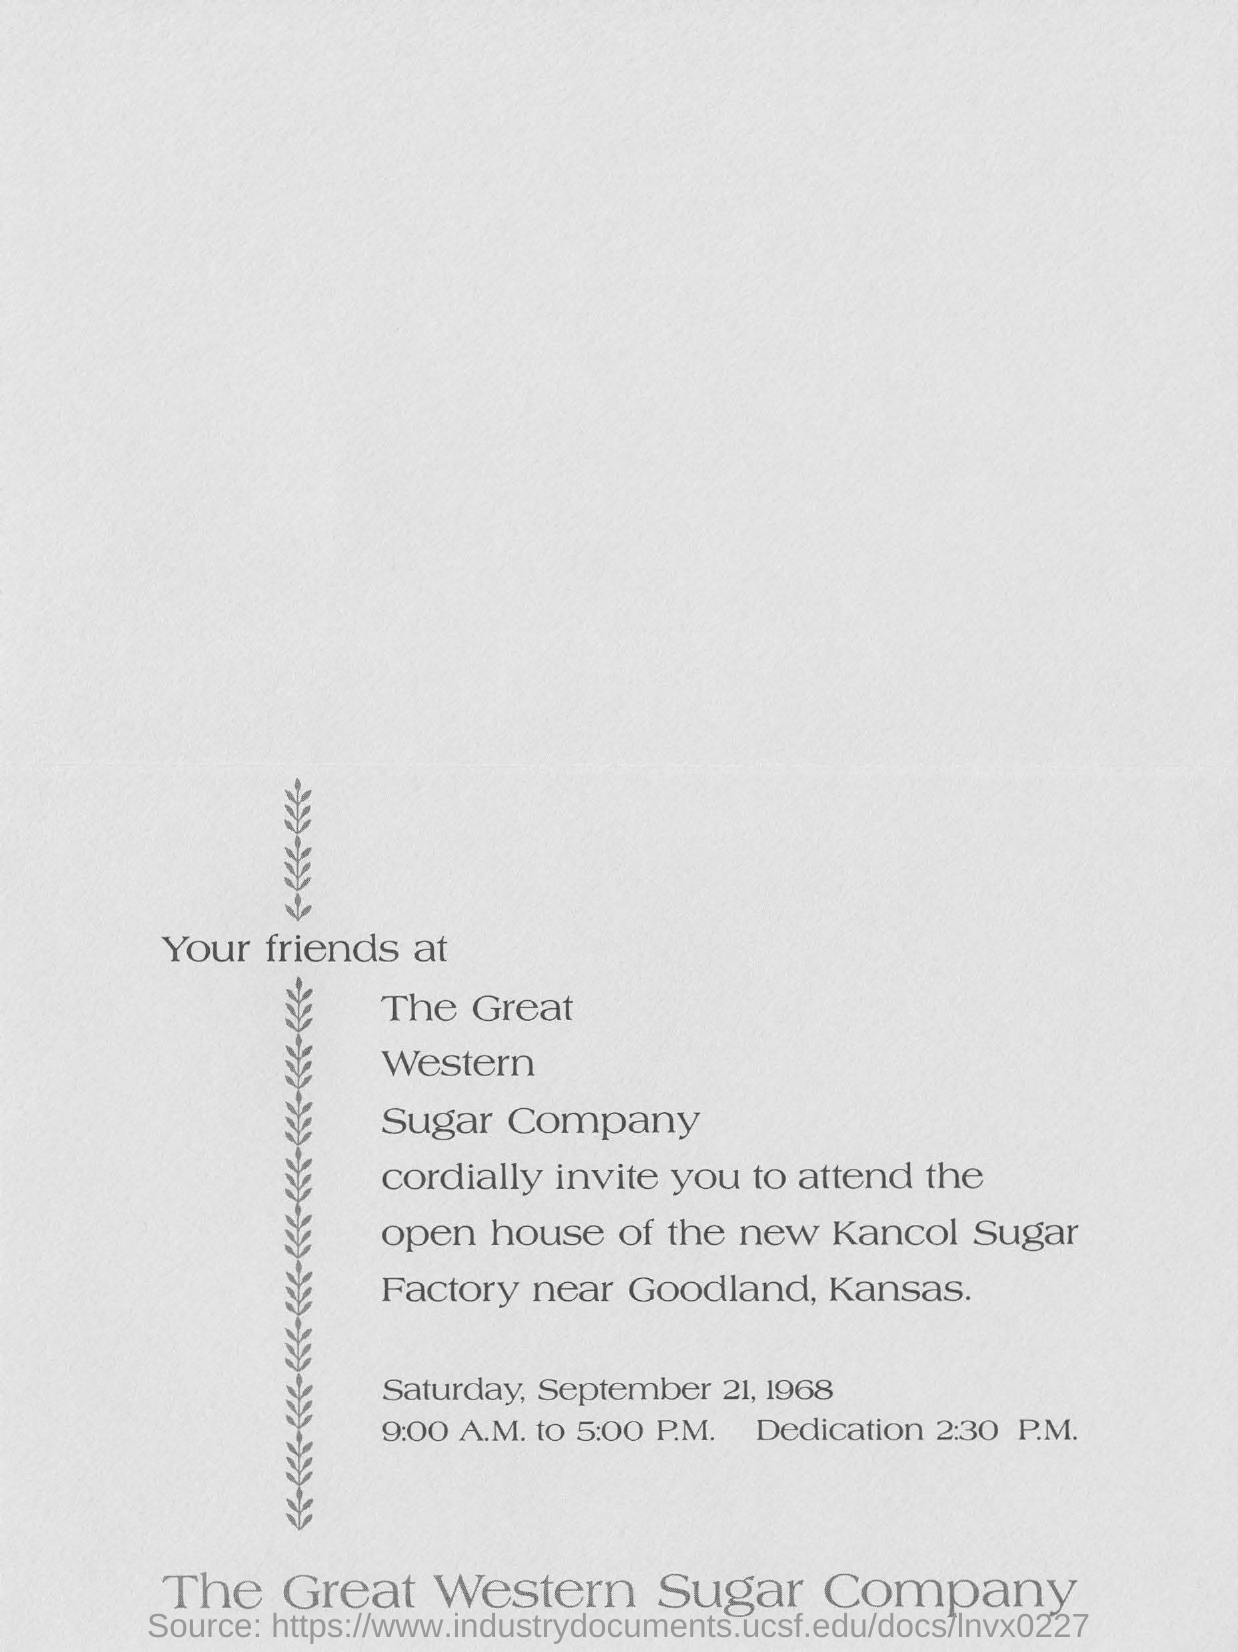List a handful of essential elements in this visual. This invitation belongs to The Great Western Sugar Company. The date mentioned in the invitation is Saturday, September 21, 1968. The dedication is scheduled for 2:30 P.M. 